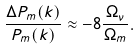Convert formula to latex. <formula><loc_0><loc_0><loc_500><loc_500>\frac { \Delta P _ { m } ( k ) } { P _ { m } ( k ) } \approx - 8 \frac { \Omega _ { \nu } } { \Omega _ { m } } .</formula> 